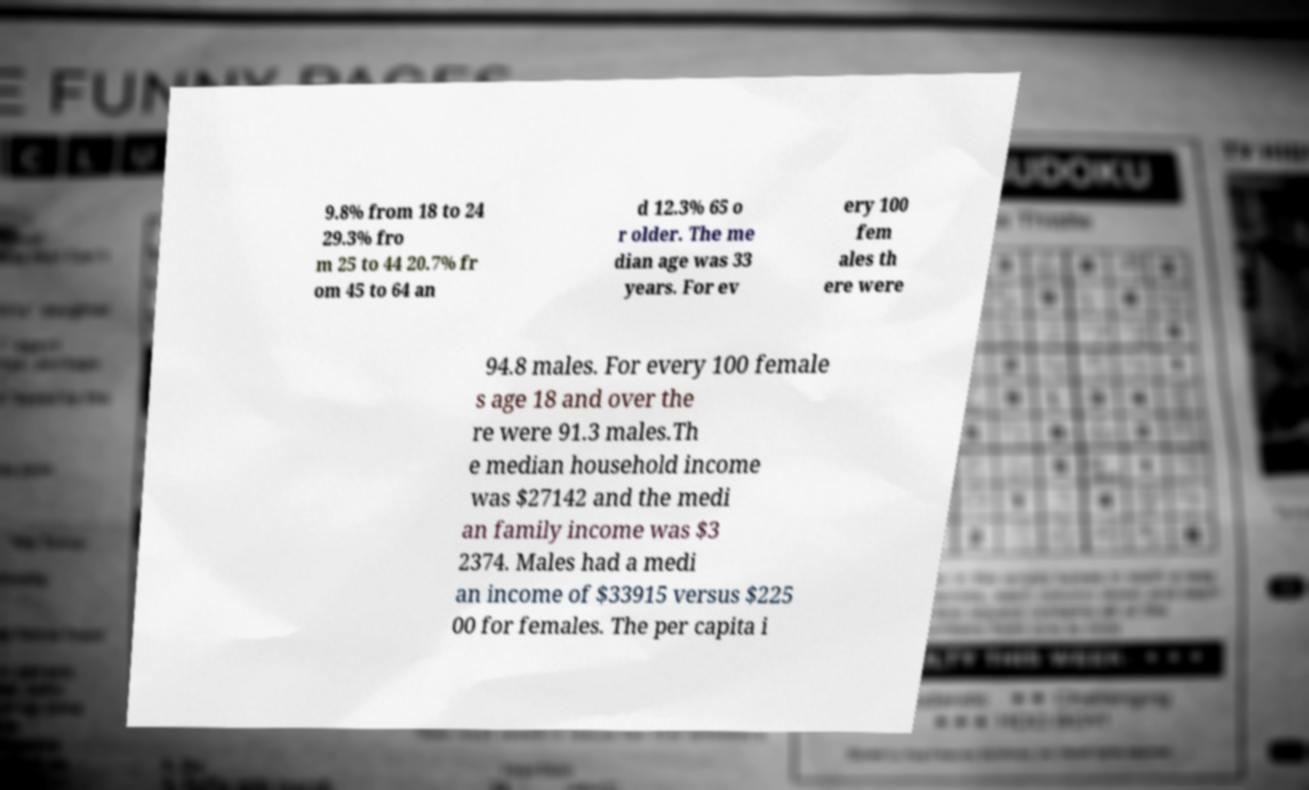Can you accurately transcribe the text from the provided image for me? 9.8% from 18 to 24 29.3% fro m 25 to 44 20.7% fr om 45 to 64 an d 12.3% 65 o r older. The me dian age was 33 years. For ev ery 100 fem ales th ere were 94.8 males. For every 100 female s age 18 and over the re were 91.3 males.Th e median household income was $27142 and the medi an family income was $3 2374. Males had a medi an income of $33915 versus $225 00 for females. The per capita i 